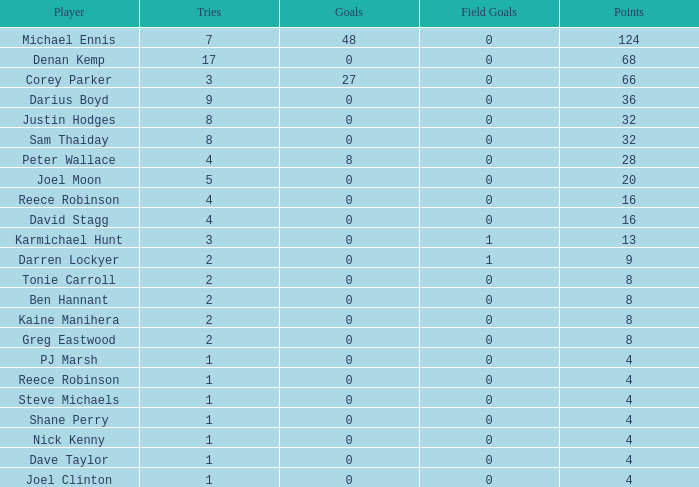What is the total number of field goals of Denan Kemp, who has more than 4 tries, more than 32 points, and 0 goals? 1.0. 